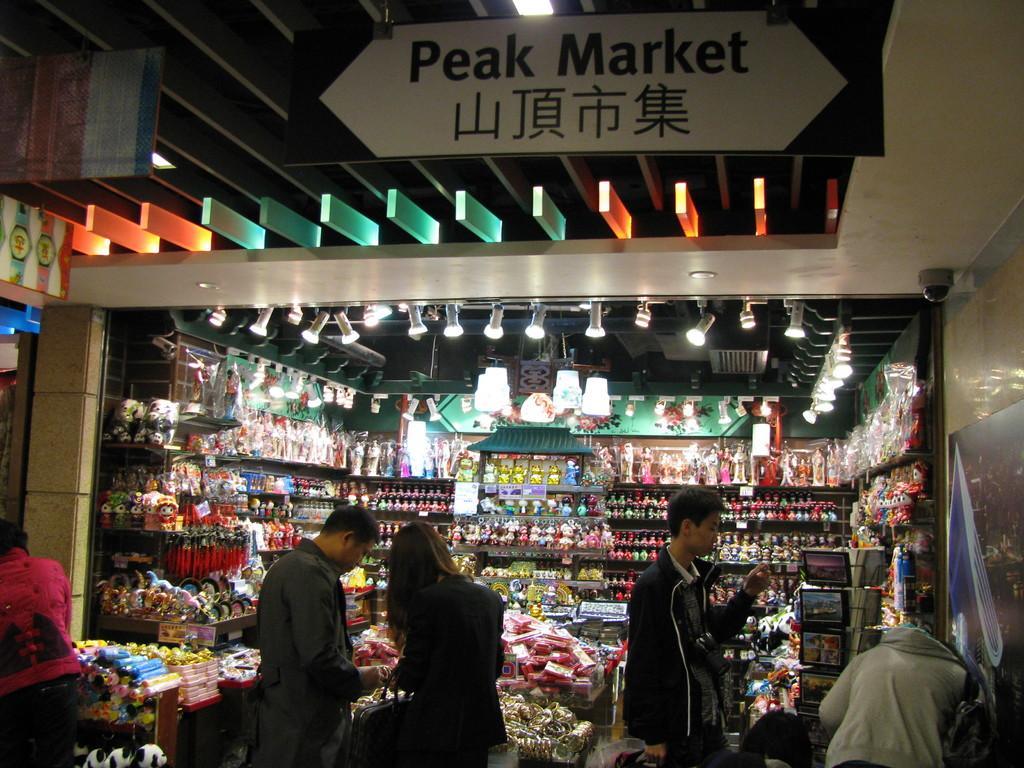Describe this image in one or two sentences. In this image we can see the view of a shop, there are shelves, there are objects on the shelves, there are three women standing towards the bottom of the image, there are two men standing towards the bottom of the image, there are lights, there is a board towards the top of the image, there is text on the board, there is an object towards the left of the image, there is a wall towards the right of the image, there is an object on the wall, there is roof towards the top of the image. 